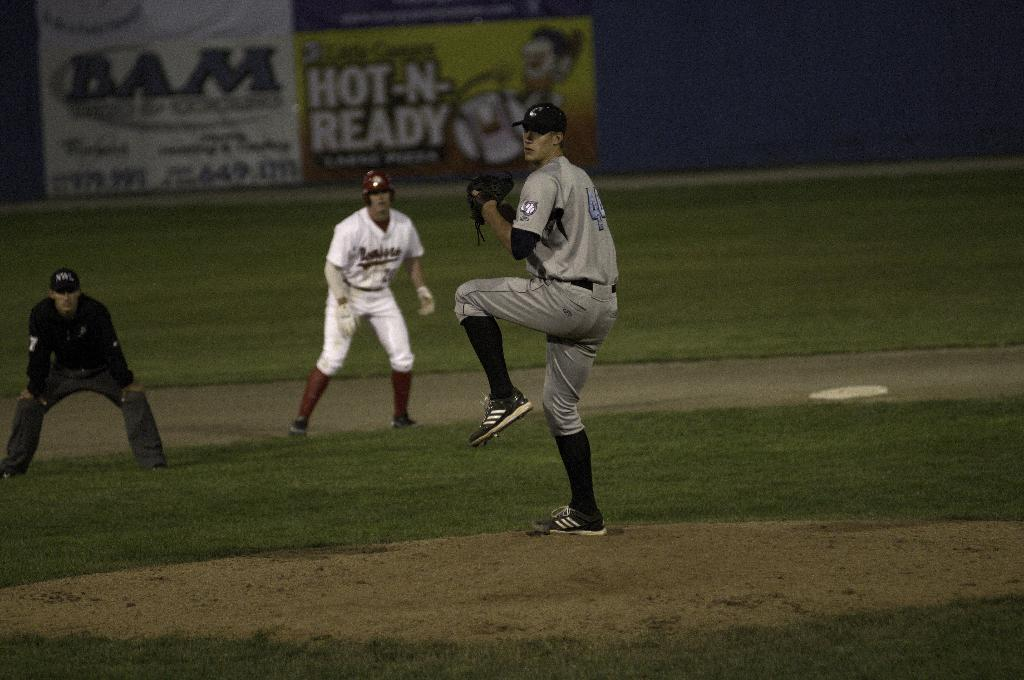<image>
Share a concise interpretation of the image provided. Behind baseball players, the advertisement on the fence is for hot -n- ready pizza. 